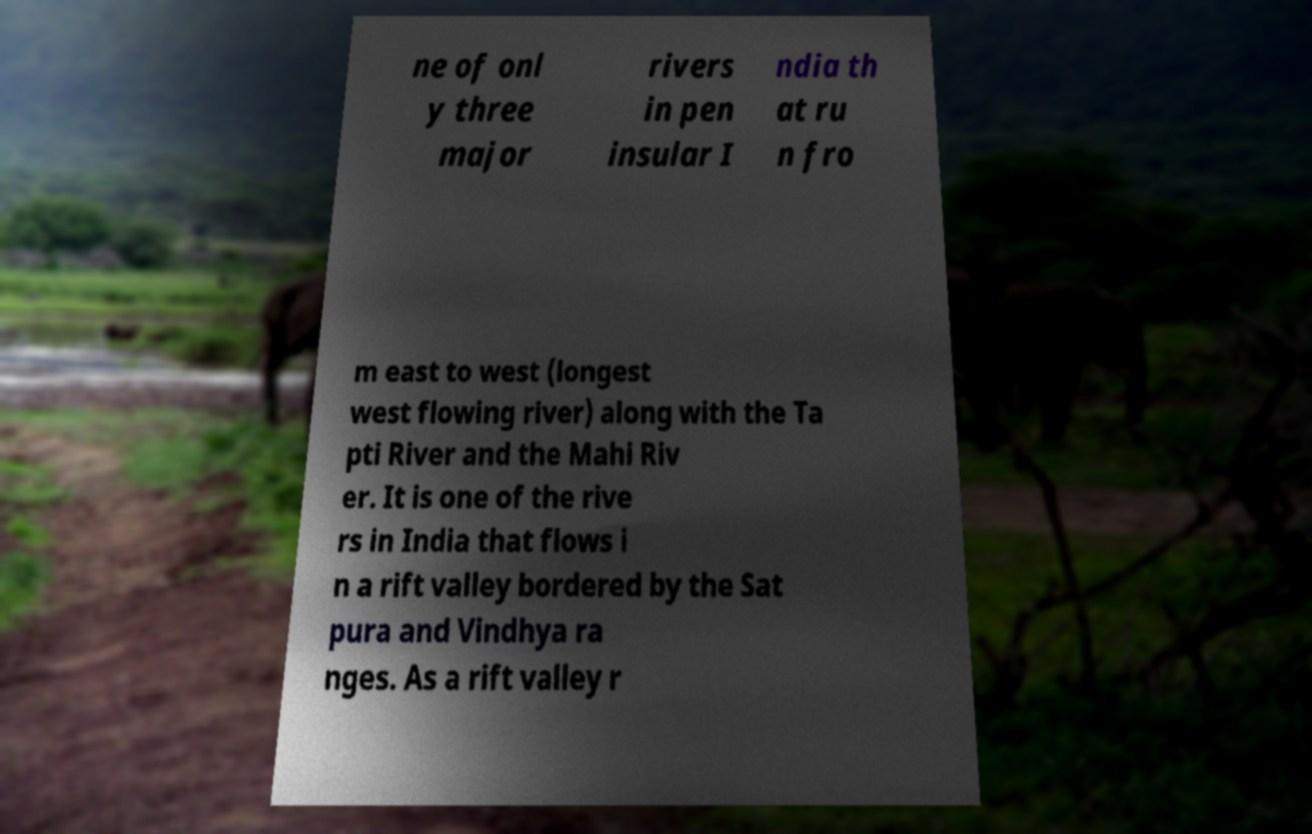Could you extract and type out the text from this image? ne of onl y three major rivers in pen insular I ndia th at ru n fro m east to west (longest west flowing river) along with the Ta pti River and the Mahi Riv er. It is one of the rive rs in India that flows i n a rift valley bordered by the Sat pura and Vindhya ra nges. As a rift valley r 